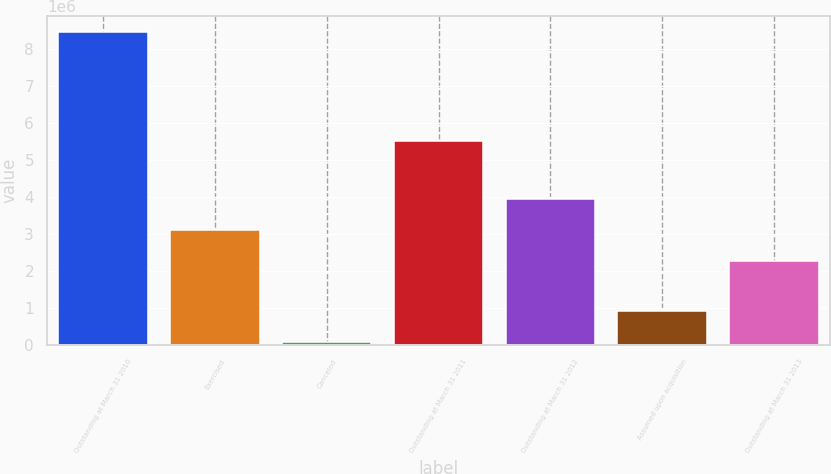Convert chart to OTSL. <chart><loc_0><loc_0><loc_500><loc_500><bar_chart><fcel>Outstanding at March 31 2010<fcel>Exercised<fcel>Canceled<fcel>Outstanding at March 31 2011<fcel>Outstanding at March 31 2012<fcel>Assumed upon acquisition<fcel>Outstanding at March 31 2013<nl><fcel>8.45978e+06<fcel>3.10803e+06<fcel>77490<fcel>5.49692e+06<fcel>3.94626e+06<fcel>915719<fcel>2.2698e+06<nl></chart> 